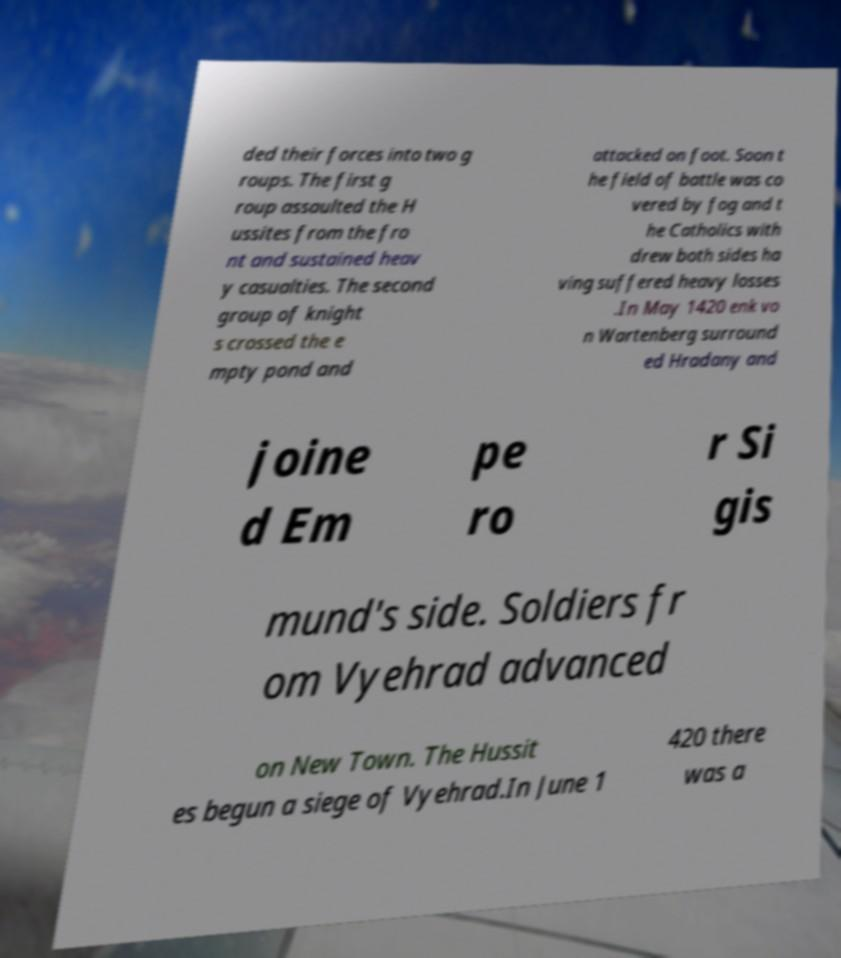Can you accurately transcribe the text from the provided image for me? ded their forces into two g roups. The first g roup assaulted the H ussites from the fro nt and sustained heav y casualties. The second group of knight s crossed the e mpty pond and attacked on foot. Soon t he field of battle was co vered by fog and t he Catholics with drew both sides ha ving suffered heavy losses .In May 1420 enk vo n Wartenberg surround ed Hradany and joine d Em pe ro r Si gis mund's side. Soldiers fr om Vyehrad advanced on New Town. The Hussit es begun a siege of Vyehrad.In June 1 420 there was a 